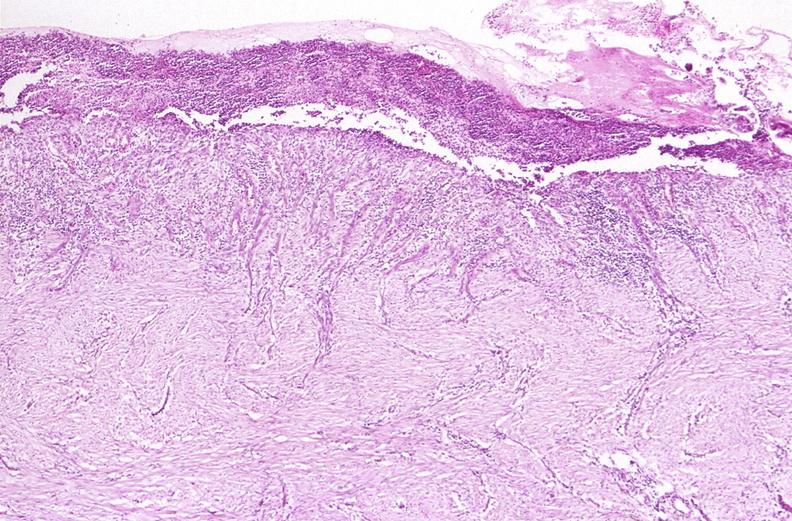s gastrointestinal present?
Answer the question using a single word or phrase. Yes 